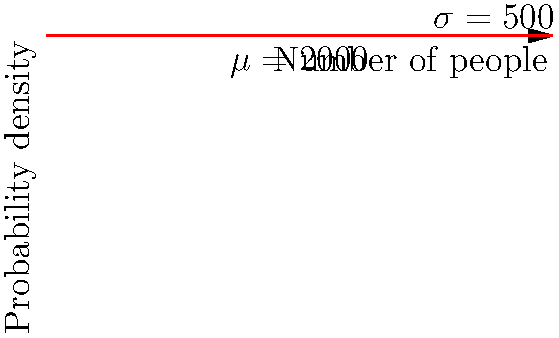At a Meghan Trainor concert, the number of attendees follows a normal distribution with a mean of 2000 and a standard deviation of 500. The probability density function (PDF) for this distribution is shown above. What is the probability that more than 2500 people attend the concert? To solve this problem, we need to follow these steps:

1) The normal distribution has a mean $\mu = 2000$ and standard deviation $\sigma = 500$.

2) We want to find $P(X > 2500)$, where $X$ is the number of attendees.

3) First, we need to standardize the value 2500 to a z-score:

   $z = \frac{x - \mu}{\sigma} = \frac{2500 - 2000}{500} = 1$

4) Now, we need to find $P(Z > 1)$, where $Z$ is the standard normal variable.

5) Using a standard normal table or calculator, we can find that $P(Z < 1) = 0.8413$.

6) Since we want $P(Z > 1)$, and the total probability is 1, we calculate:

   $P(Z > 1) = 1 - P(Z < 1) = 1 - 0.8413 = 0.1587$

7) Therefore, the probability that more than 2500 people attend the concert is approximately 0.1587 or 15.87%.
Answer: 0.1587 